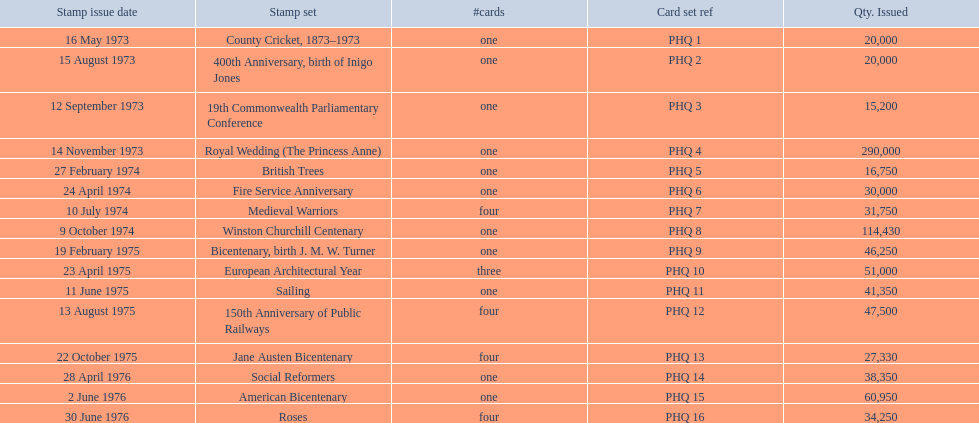What are all the stamp series? County Cricket, 1873–1973, 400th Anniversary, birth of Inigo Jones, 19th Commonwealth Parliamentary Conference, Royal Wedding (The Princess Anne), British Trees, Fire Service Anniversary, Medieval Warriors, Winston Churchill Centenary, Bicentenary, birth J. M. W. Turner, European Architectural Year, Sailing, 150th Anniversary of Public Railways, Jane Austen Bicentenary, Social Reformers, American Bicentenary, Roses. Which of these series has three cards in it? European Architectural Year. 